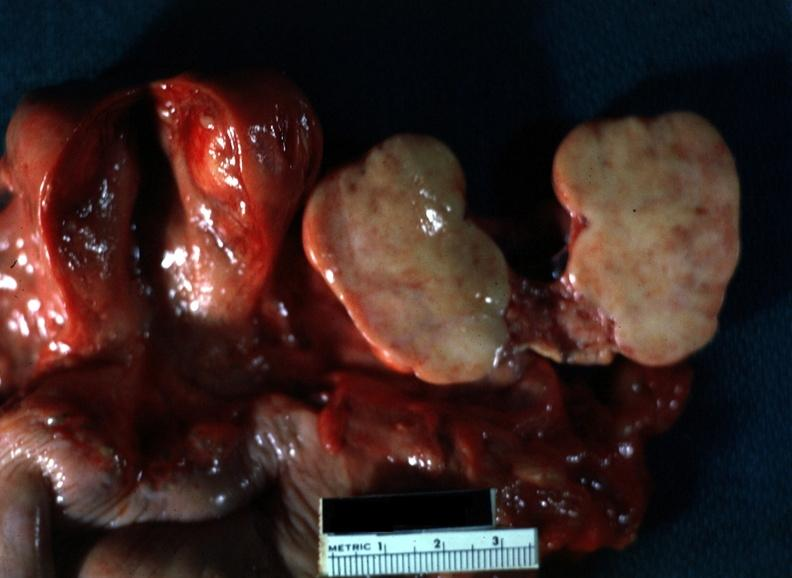where does this belong to?
Answer the question using a single word or phrase. Female reproductive system 